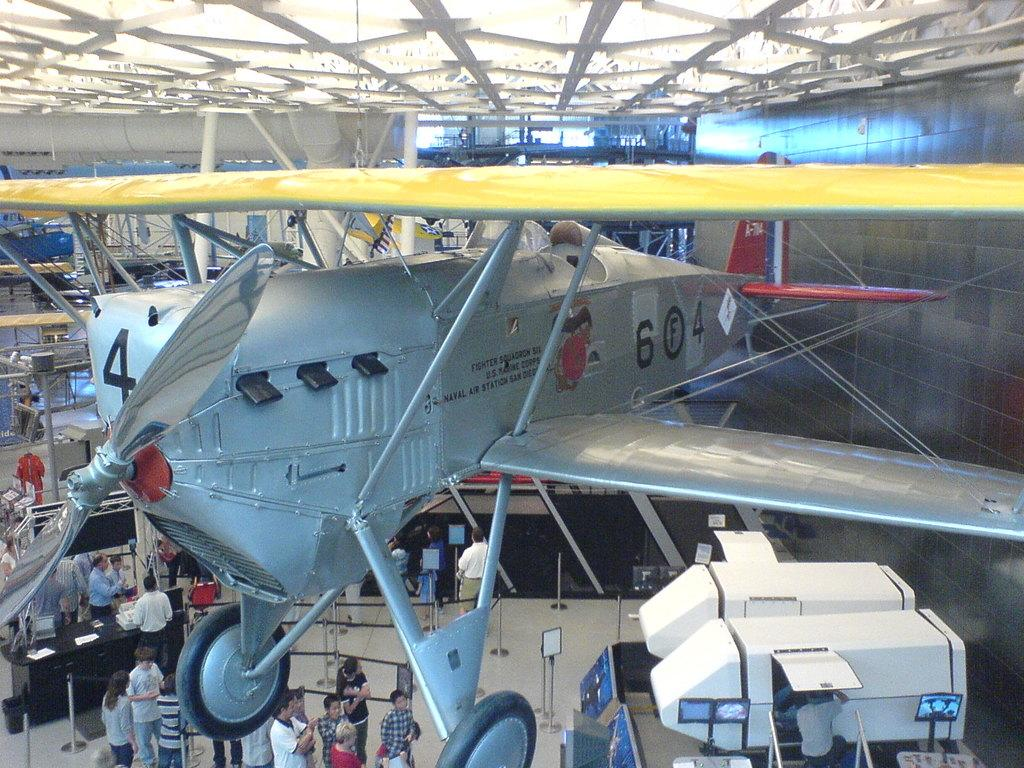What is the main subject in the center of the image? There is a helicopter in the center of the image. What can be seen at the bottom of the image? There are people standing at the bottom of the image. What types of vehicles are visible on the right side of the image? There are vehicles on the right side of the image. What structures can be seen in the background of the image? There is a roof and a wall in the background of the image. What type of stew is being prepared by the helicopter in the image? There is no stew being prepared in the image; the main subject is a helicopter. What substance is being compared between the roof and the wall in the image? There is no comparison of substances between the roof and the wall in the image. 